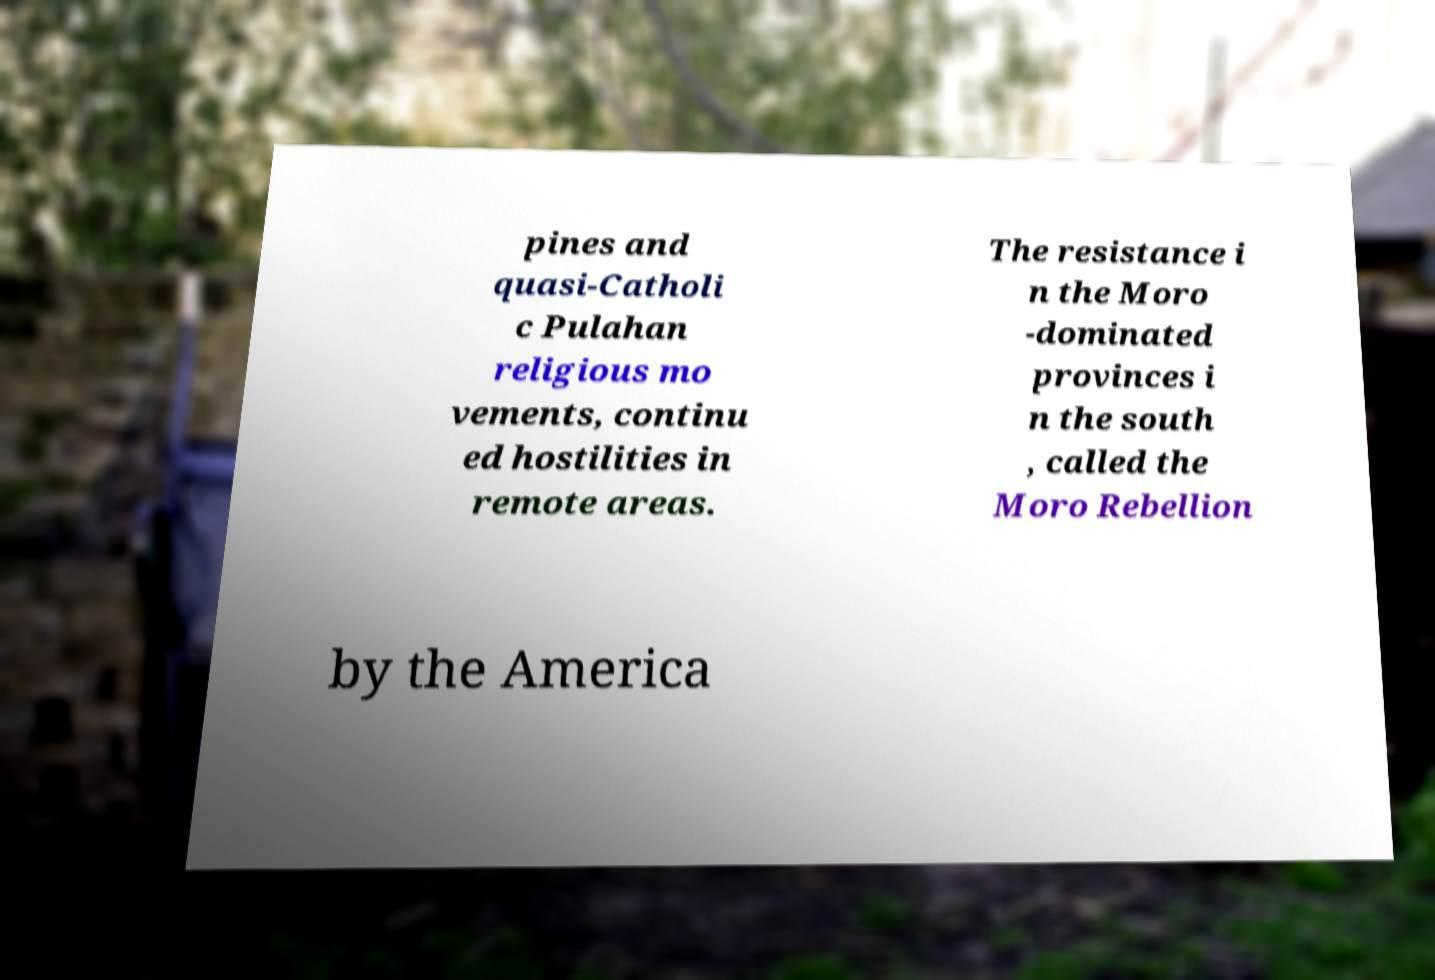Could you assist in decoding the text presented in this image and type it out clearly? pines and quasi-Catholi c Pulahan religious mo vements, continu ed hostilities in remote areas. The resistance i n the Moro -dominated provinces i n the south , called the Moro Rebellion by the America 